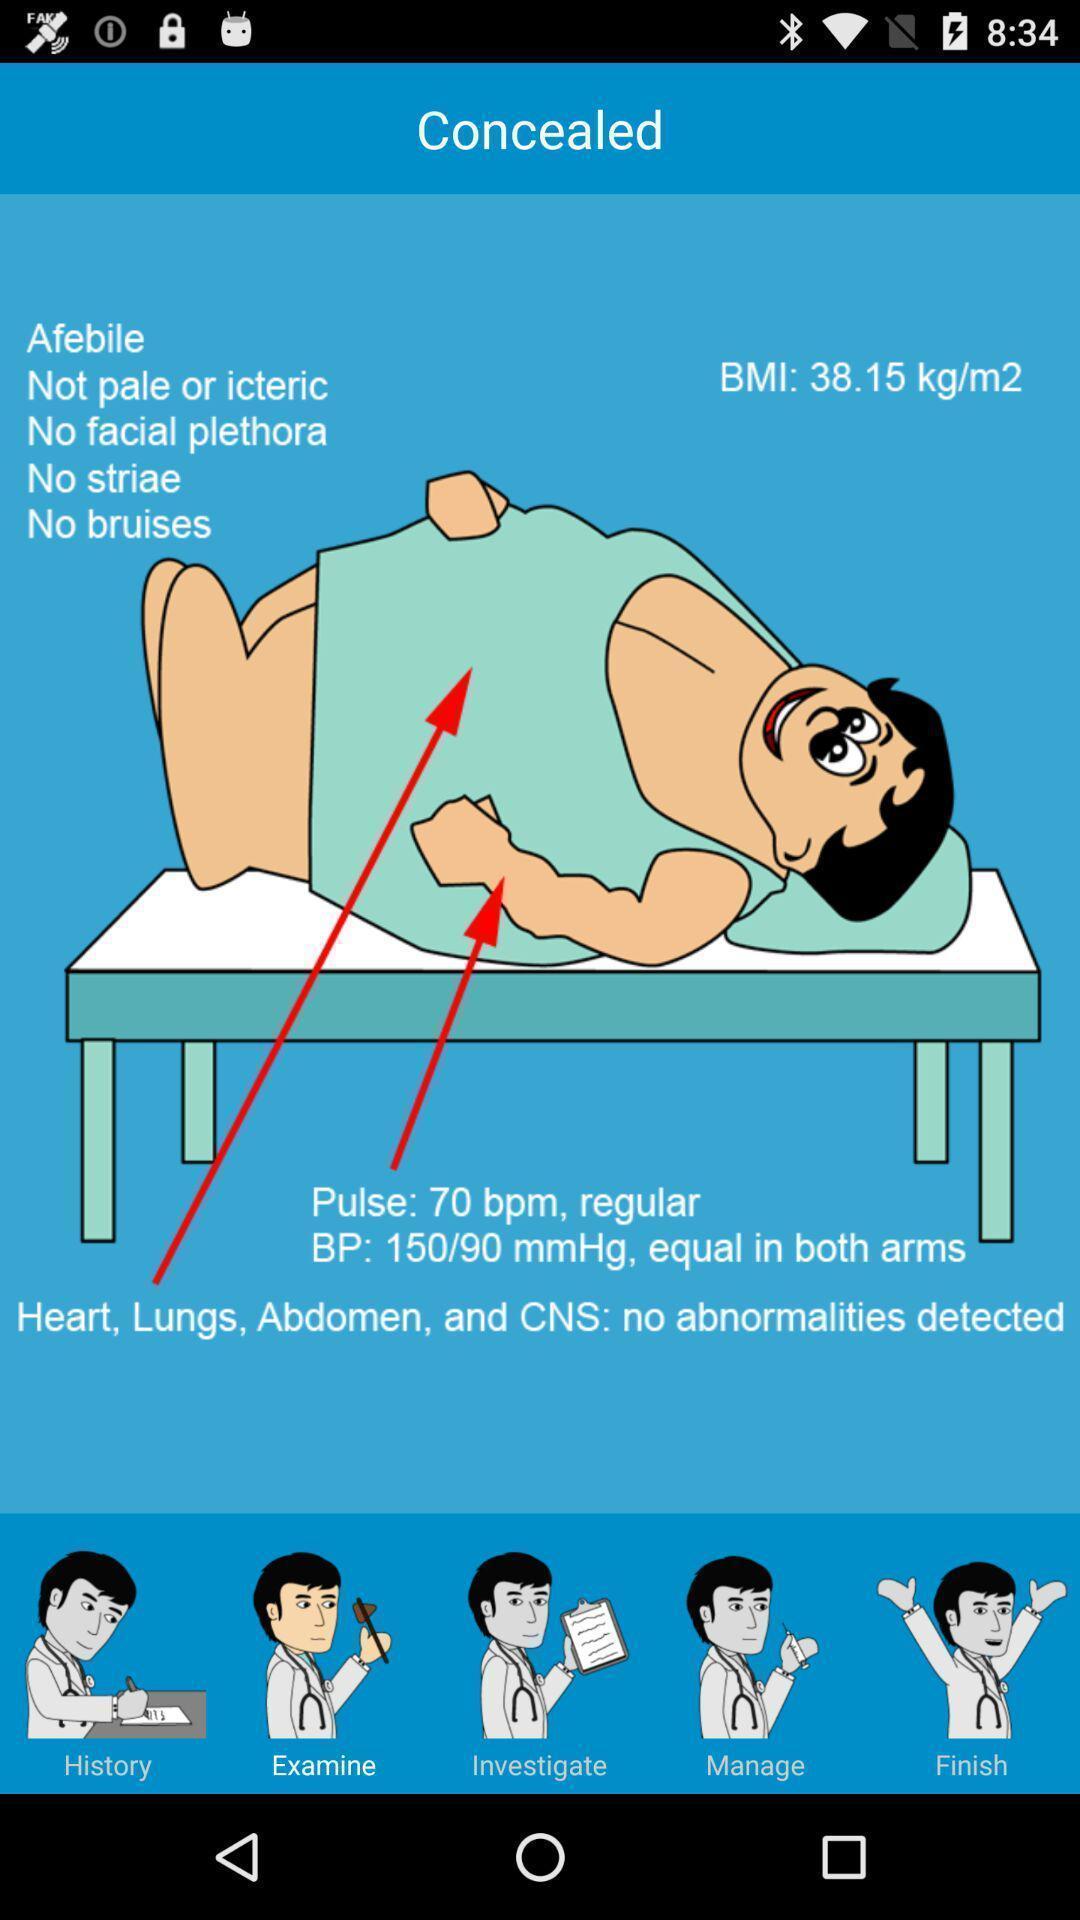Explain the elements present in this screenshot. Screen displaying diagnosis of a man. 